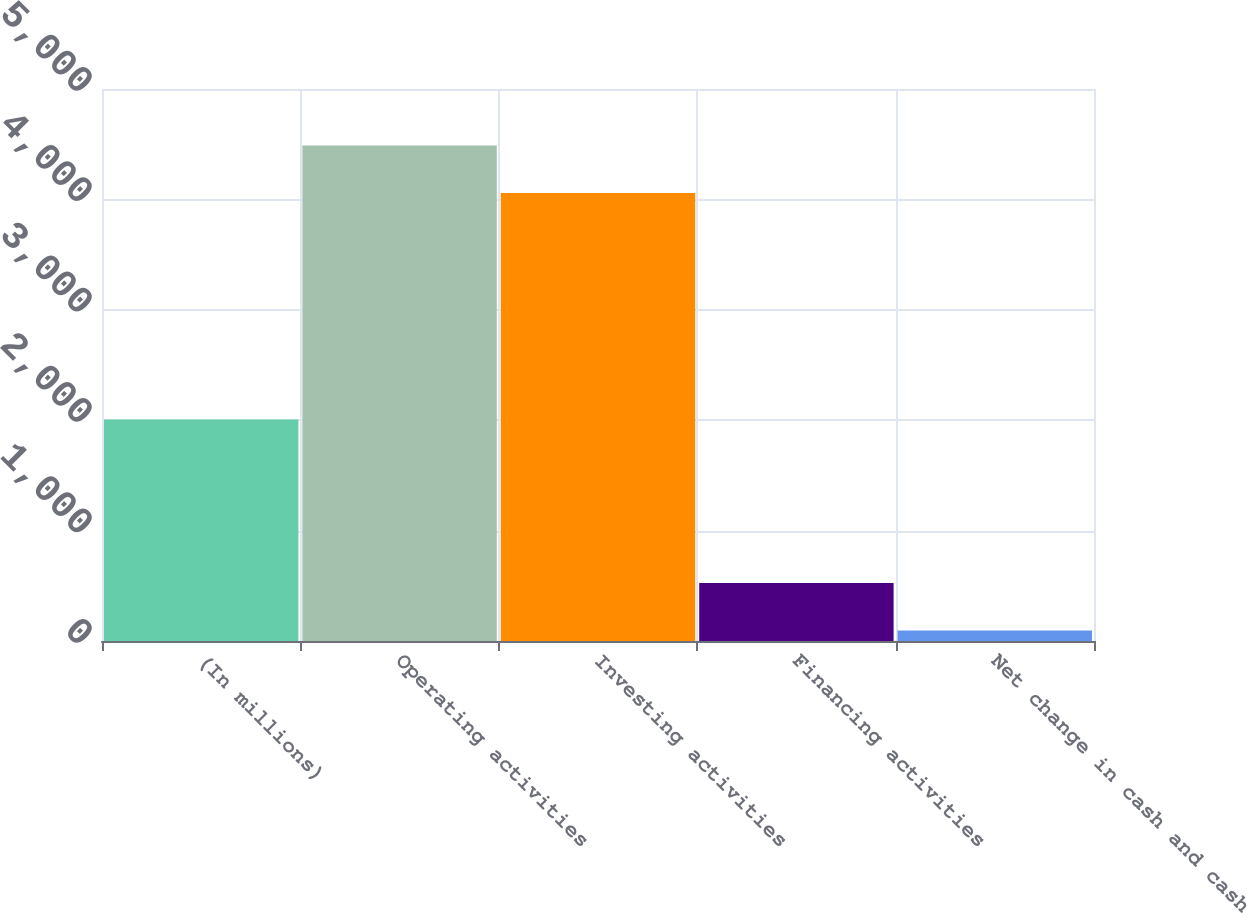Convert chart to OTSL. <chart><loc_0><loc_0><loc_500><loc_500><bar_chart><fcel>(In millions)<fcel>Operating activities<fcel>Investing activities<fcel>Financing activities<fcel>Net change in cash and cash<nl><fcel>2006<fcel>4487.3<fcel>4057<fcel>524.3<fcel>94<nl></chart> 